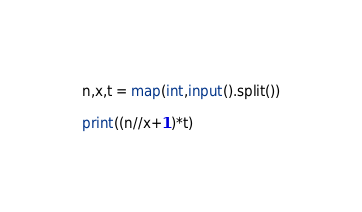Convert code to text. <code><loc_0><loc_0><loc_500><loc_500><_Python_>n,x,t = map(int,input().split())

print((n//x+1)*t)</code> 